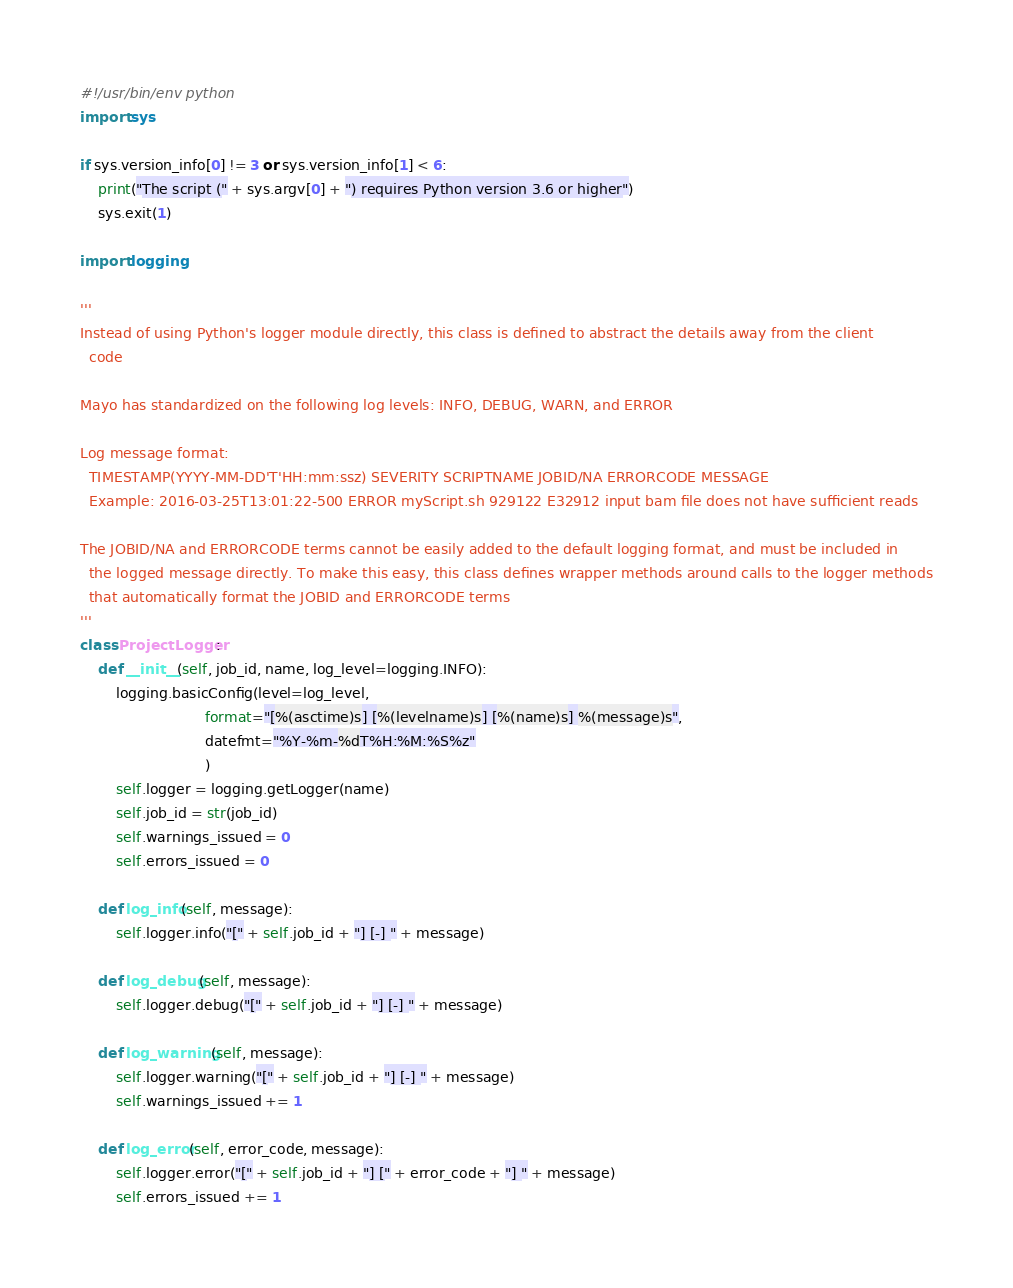<code> <loc_0><loc_0><loc_500><loc_500><_Python_>#!/usr/bin/env python
import sys

if sys.version_info[0] != 3 or sys.version_info[1] < 6:
    print("The script (" + sys.argv[0] + ") requires Python version 3.6 or higher")
    sys.exit(1)

import logging

'''
Instead of using Python's logger module directly, this class is defined to abstract the details away from the client
  code

Mayo has standardized on the following log levels: INFO, DEBUG, WARN, and ERROR

Log message format:
  TIMESTAMP(YYYY-MM-DD'T'HH:mm:ssz) SEVERITY SCRIPTNAME JOBID/NA ERRORCODE MESSAGE
  Example: 2016-03-25T13:01:22-500 ERROR myScript.sh 929122 E32912 input bam file does not have sufficient reads

The JOBID/NA and ERRORCODE terms cannot be easily added to the default logging format, and must be included in
  the logged message directly. To make this easy, this class defines wrapper methods around calls to the logger methods
  that automatically format the JOBID and ERRORCODE terms
'''
class ProjectLogger:
    def __init__(self, job_id, name, log_level=logging.INFO):
        logging.basicConfig(level=log_level,
                            format="[%(asctime)s] [%(levelname)s] [%(name)s] %(message)s",
                            datefmt="%Y-%m-%dT%H:%M:%S%z"
                            )
        self.logger = logging.getLogger(name)
        self.job_id = str(job_id)
        self.warnings_issued = 0
        self.errors_issued = 0

    def log_info(self, message):
        self.logger.info("[" + self.job_id + "] [-] " + message)

    def log_debug(self, message):
        self.logger.debug("[" + self.job_id + "] [-] " + message)

    def log_warning(self, message):
        self.logger.warning("[" + self.job_id + "] [-] " + message)
        self.warnings_issued += 1

    def log_error(self, error_code, message):
        self.logger.error("[" + self.job_id + "] [" + error_code + "] " + message)
        self.errors_issued += 1
</code> 